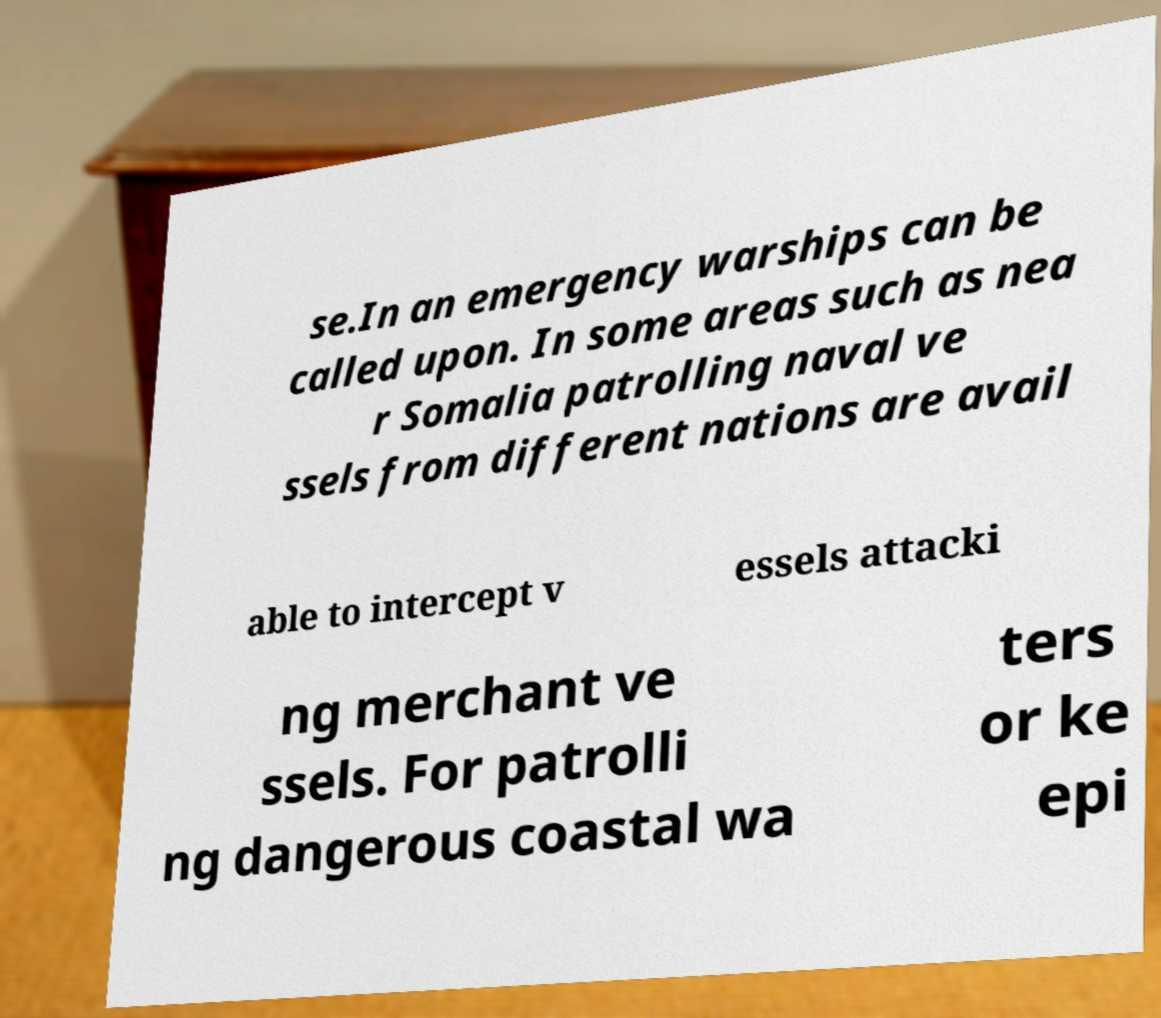There's text embedded in this image that I need extracted. Can you transcribe it verbatim? se.In an emergency warships can be called upon. In some areas such as nea r Somalia patrolling naval ve ssels from different nations are avail able to intercept v essels attacki ng merchant ve ssels. For patrolli ng dangerous coastal wa ters or ke epi 